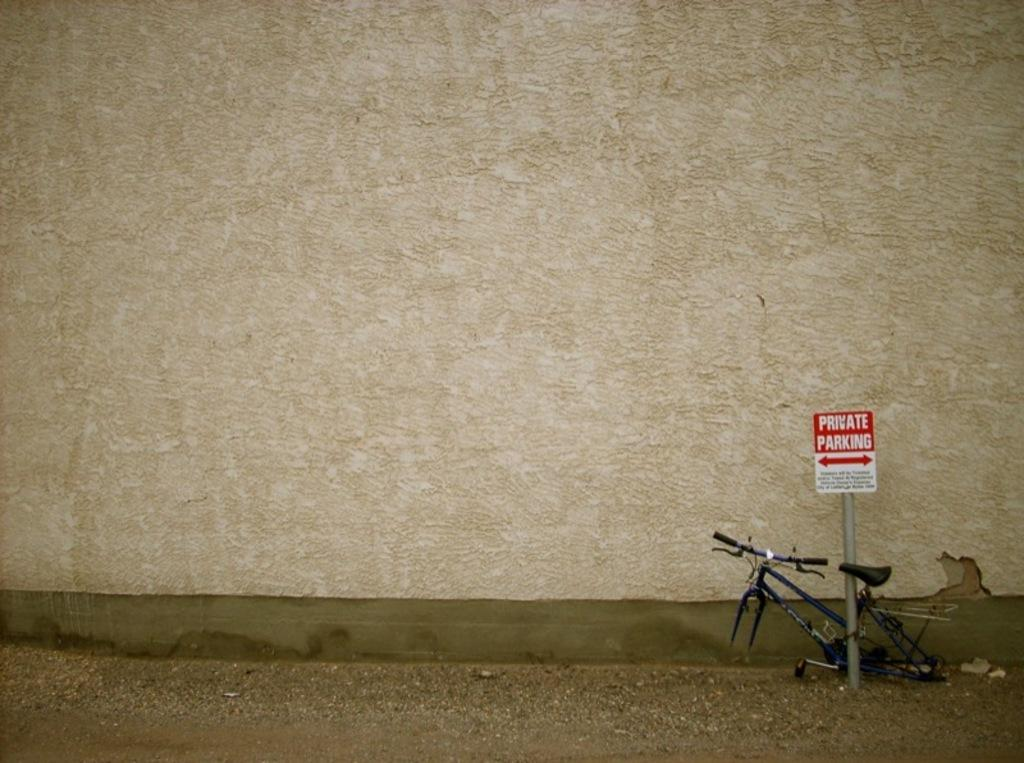What can be seen on the right side of the image? There is a frame of a cycle on the right side of the image. What is the color of the parking board in the image? The parking board in the image is red. What is the background of the image made up of? There is a wall in the image. What is the value of the trade agreement depicted in the image? There is no trade agreement or any indication of a trade agreement in the image. How many teeth can be seen in the image? There are no teeth visible in the image. 